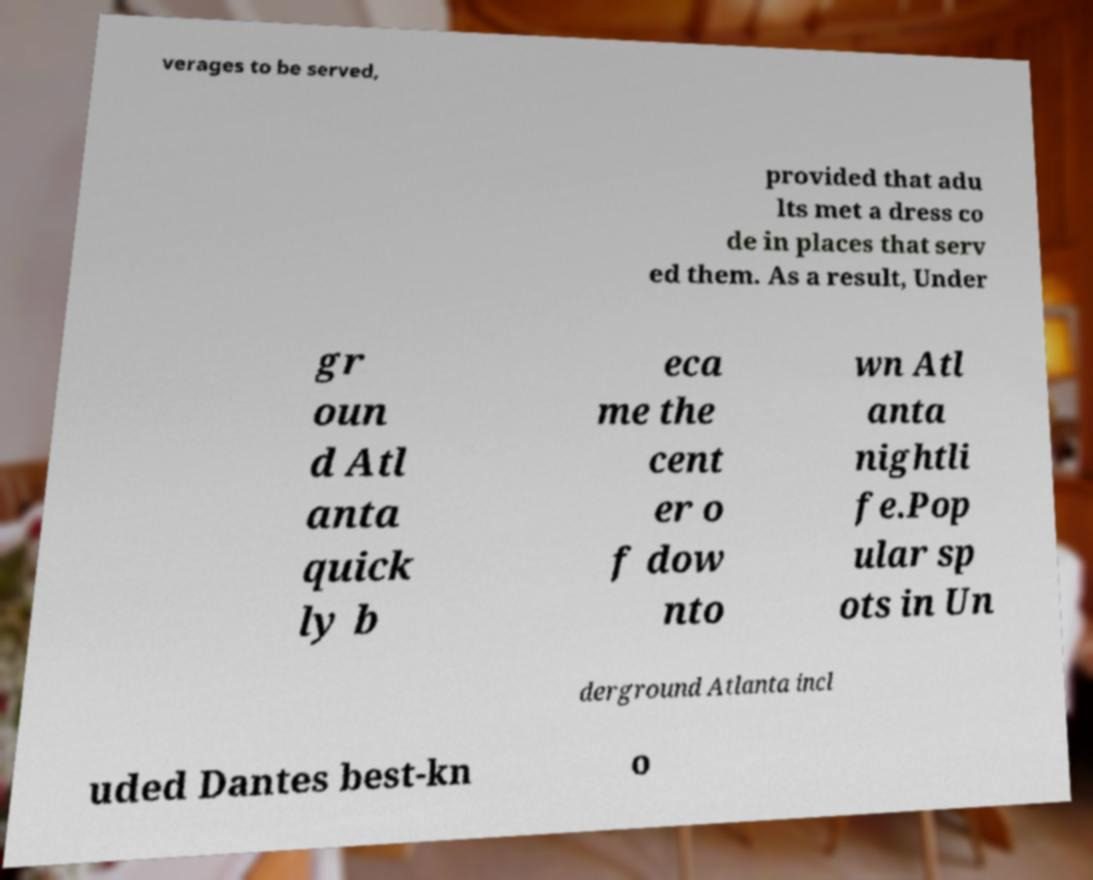Could you assist in decoding the text presented in this image and type it out clearly? verages to be served, provided that adu lts met a dress co de in places that serv ed them. As a result, Under gr oun d Atl anta quick ly b eca me the cent er o f dow nto wn Atl anta nightli fe.Pop ular sp ots in Un derground Atlanta incl uded Dantes best-kn o 